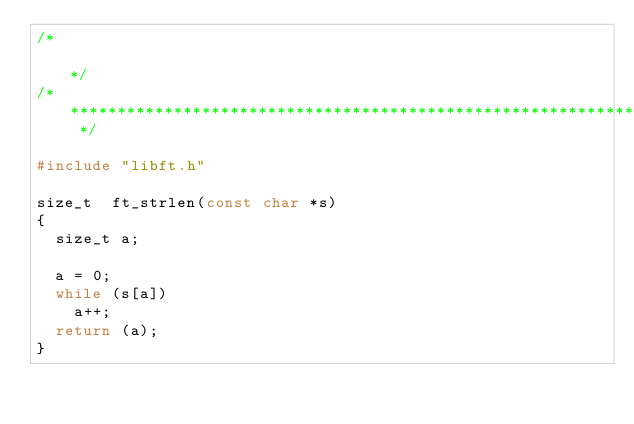Convert code to text. <code><loc_0><loc_0><loc_500><loc_500><_C_>/*                                                                            */
/* ************************************************************************** */

#include "libft.h"

size_t	ft_strlen(const char *s)
{
	size_t a;

	a = 0;
	while (s[a])
		a++;
	return (a);
}
</code> 